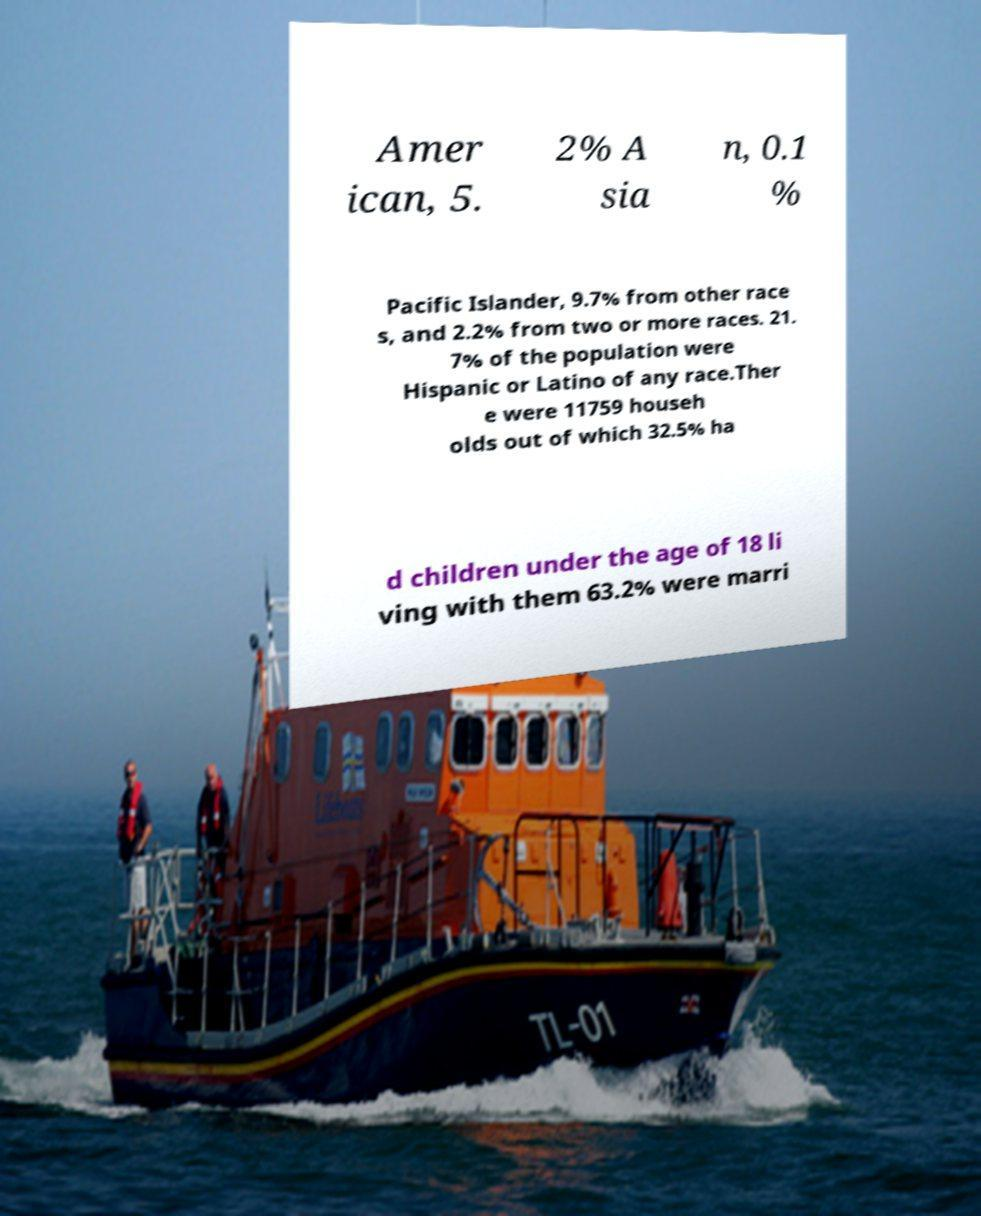What messages or text are displayed in this image? I need them in a readable, typed format. Amer ican, 5. 2% A sia n, 0.1 % Pacific Islander, 9.7% from other race s, and 2.2% from two or more races. 21. 7% of the population were Hispanic or Latino of any race.Ther e were 11759 househ olds out of which 32.5% ha d children under the age of 18 li ving with them 63.2% were marri 